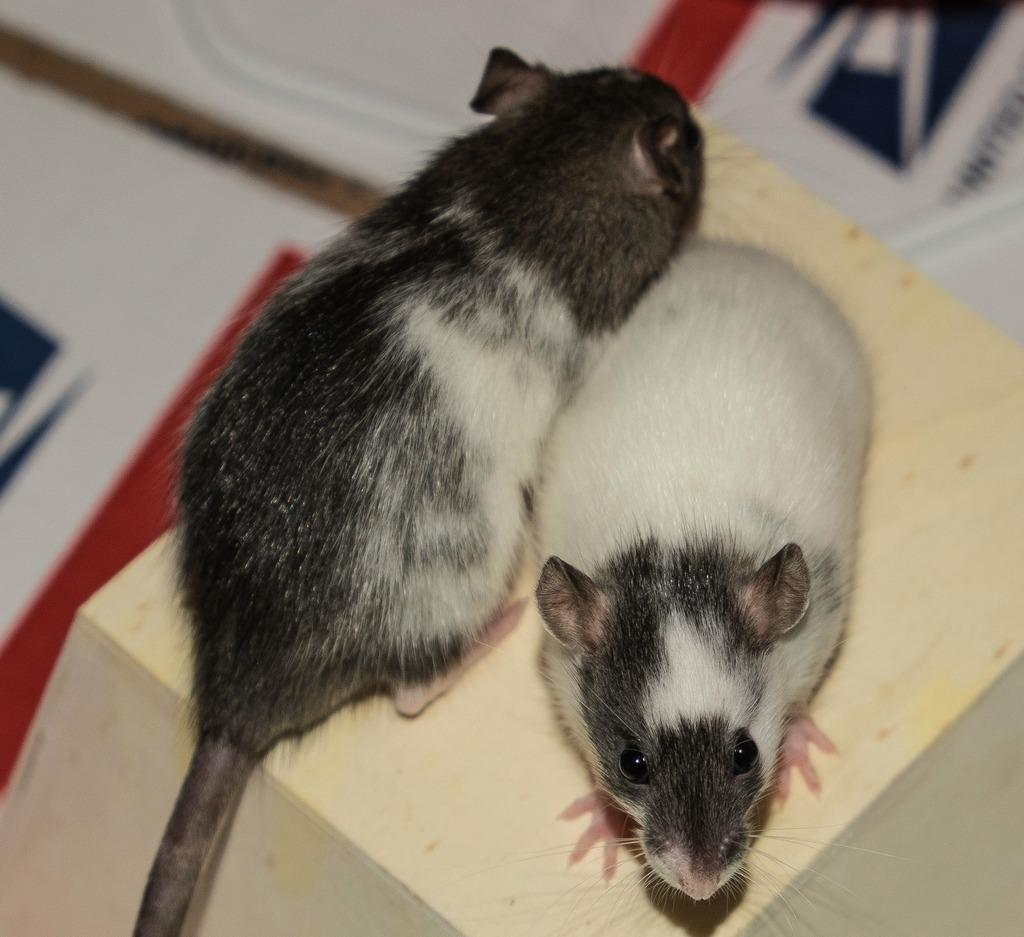What animals are present in the image? There are two rats in the image. What are the rats standing on in the image? The rats are standing on a wood block. What type of place is depicted in the image? The image does not depict a specific place; it only features two rats standing on a wood block. How many baskets can be seen in the image? There are no baskets present in the image. What month is it in the image? The image does not provide any information about the month or time of year. 